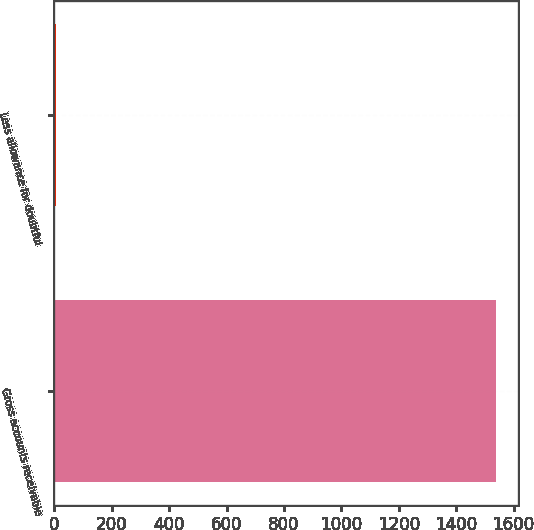Convert chart to OTSL. <chart><loc_0><loc_0><loc_500><loc_500><bar_chart><fcel>Gross accounts receivable<fcel>Less allowance for doubtful<nl><fcel>1537.2<fcel>6.2<nl></chart> 